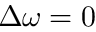Convert formula to latex. <formula><loc_0><loc_0><loc_500><loc_500>\Delta \omega = 0</formula> 